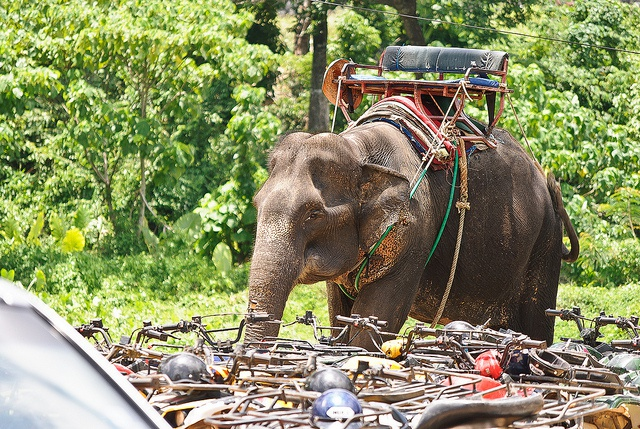Describe the objects in this image and their specific colors. I can see elephant in olive, black, maroon, and gray tones, car in olive, white, gray, darkgray, and lightblue tones, bench in olive, gray, lightgray, darkgray, and black tones, bicycle in olive, white, darkgray, and gray tones, and bicycle in olive, lightgray, gray, black, and darkgray tones in this image. 